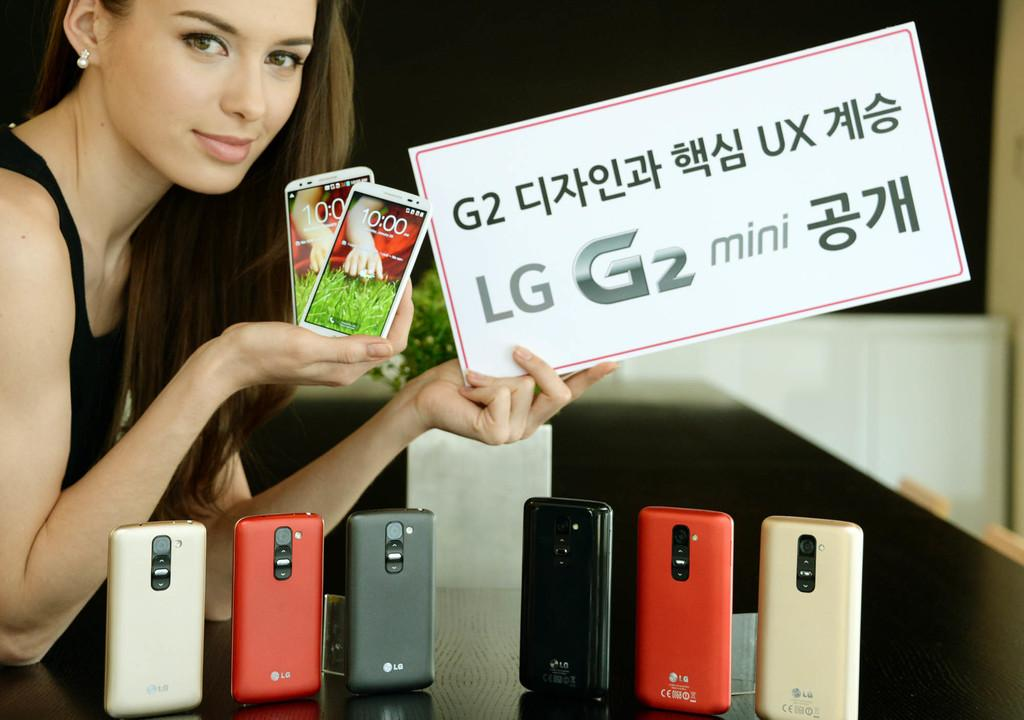<image>
Give a short and clear explanation of the subsequent image. The woman is advertising LG phones and holding several of them. 